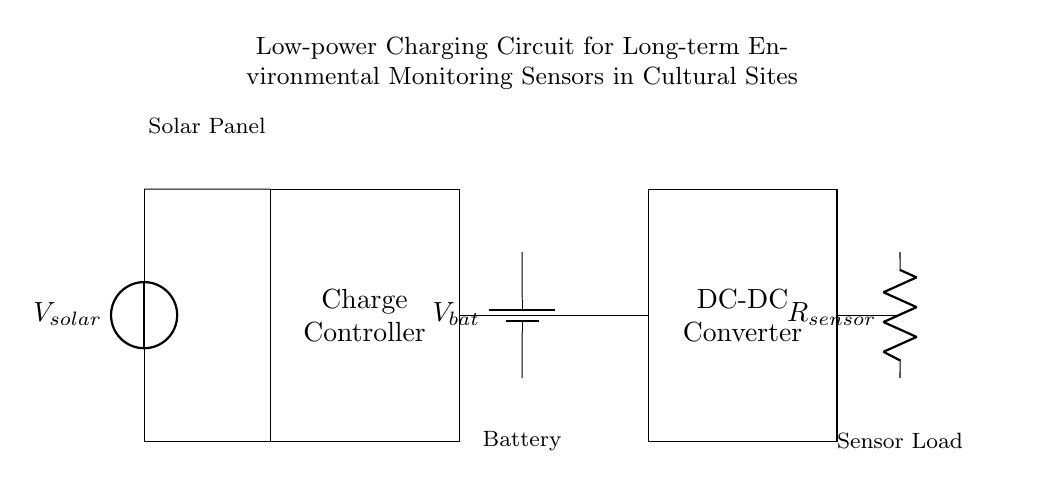What is the function of the solar panel in this circuit? The solar panel provides input voltage to the circuit, specifically labeled as V_solar. It converts solar energy into electrical energy, which powers the system.
Answer: V_solar What component connects the solar panel to the charge controller? The solar panel is connected to the charge controller through short connections that maintain the flow of current.
Answer: Short connections What is the role of the charge controller in this circuit? The charge controller regulates the voltage and current coming from the solar panel to ensure the battery is charged safely without overcharging.
Answer: Regulates battery charging What type of component is represented by R_sensor? R_sensor is represented as a resistor, which in this circuit denotes the sensor load that uses the supplied voltage.
Answer: Resistor How does the DC-DC converter function in this circuit? The DC-DC converter adjusts the voltage from the battery to the level required by the sensor load, ensuring that it operates within its specifications.
Answer: Voltage adjustment What is the output of the battery labeled as? The output of the battery is labeled as V_bat, representing the battery voltage supplied to the circuit.
Answer: V_bat How does the circuit ensure long-term environmental monitoring? The circuit employs a solar panel for sustainable energy, a charge controller for maintaining battery health, and a low-power sensor load for prolonged operation with minimal power use.
Answer: Sustainable energy method 